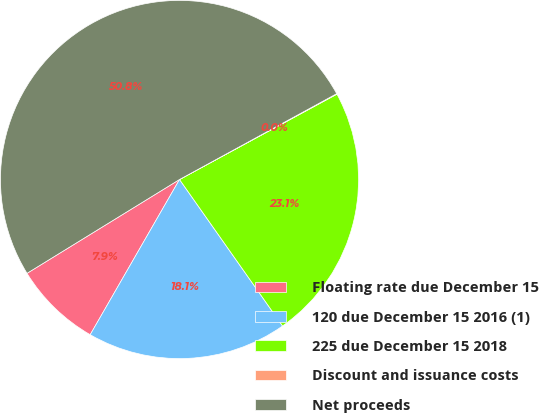<chart> <loc_0><loc_0><loc_500><loc_500><pie_chart><fcel>Floating rate due December 15<fcel>120 due December 15 2016 (1)<fcel>225 due December 15 2018<fcel>Discount and issuance costs<fcel>Net proceeds<nl><fcel>7.91%<fcel>18.07%<fcel>23.15%<fcel>0.05%<fcel>50.83%<nl></chart> 